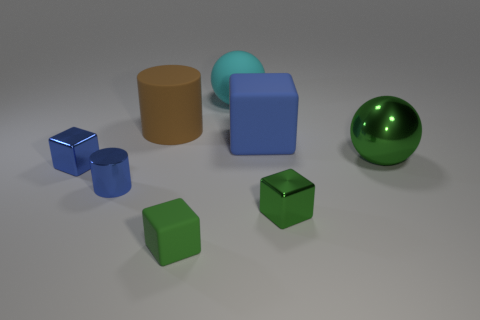What is the size of the shiny thing that is the same shape as the large cyan rubber thing?
Keep it short and to the point. Large. Does the large rubber cylinder have the same color as the metallic cube that is on the right side of the blue shiny cylinder?
Offer a terse response. No. What number of other objects are the same size as the blue metal cylinder?
Offer a terse response. 3. What shape is the small metallic object that is to the right of the blue block that is behind the tiny shiny cube that is on the left side of the brown cylinder?
Ensure brevity in your answer.  Cube. Do the green sphere and the blue thing right of the matte cylinder have the same size?
Your answer should be compact. Yes. What is the color of the cube that is behind the metallic cylinder and right of the brown matte cylinder?
Keep it short and to the point. Blue. How many other things are the same shape as the blue rubber thing?
Offer a very short reply. 3. Does the tiny cube to the left of the rubber cylinder have the same color as the large sphere that is behind the big blue object?
Your answer should be very brief. No. Is the size of the sphere in front of the brown cylinder the same as the blue thing that is to the right of the big cyan sphere?
Your answer should be compact. Yes. Is there anything else that has the same material as the blue cylinder?
Your answer should be compact. Yes. 